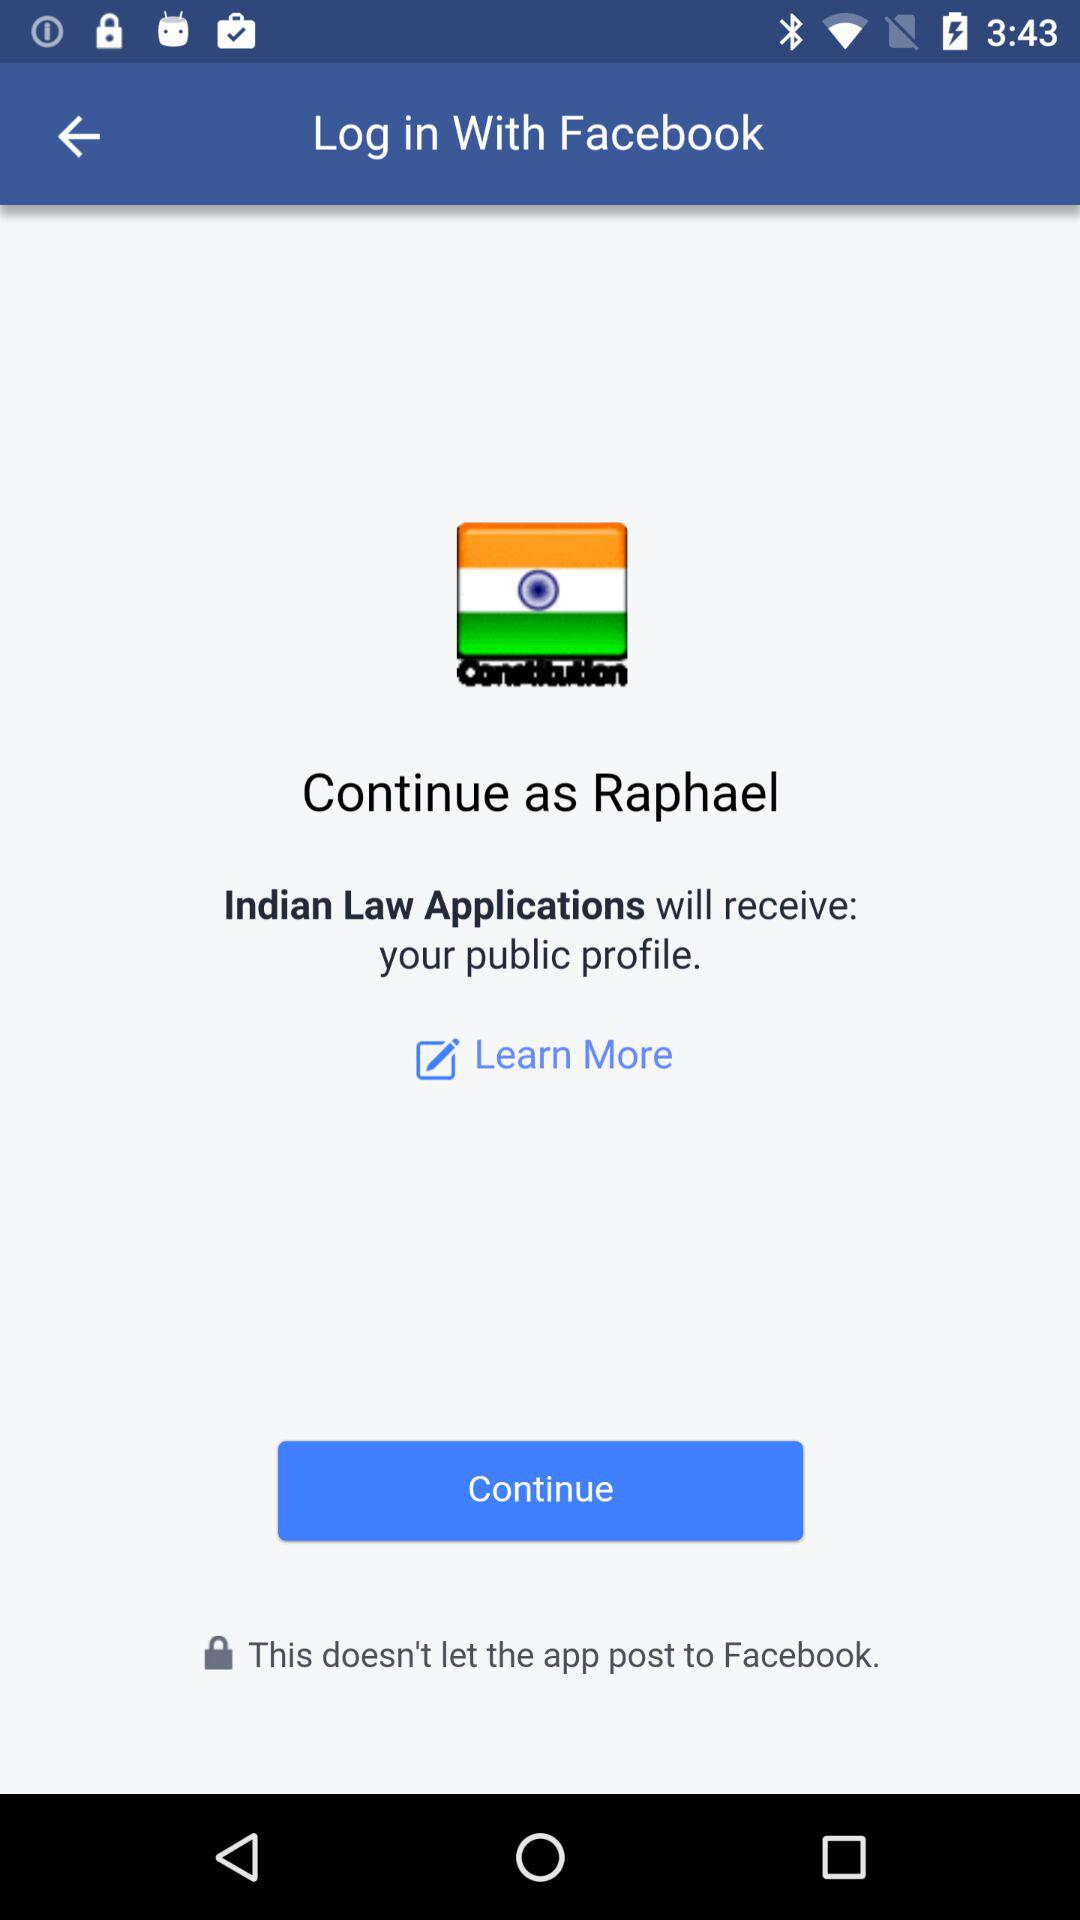What is the name of the user? The name of the user is Raphael. 